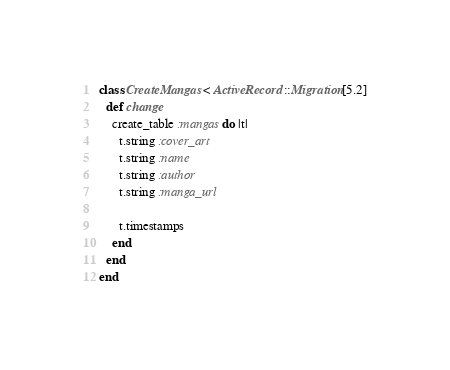Convert code to text. <code><loc_0><loc_0><loc_500><loc_500><_Ruby_>class CreateMangas < ActiveRecord::Migration[5.2]
  def change
    create_table :mangas do |t|
      t.string :cover_art
      t.string :name
      t.string :author
      t.string :manga_url

      t.timestamps
    end
  end
end
</code> 